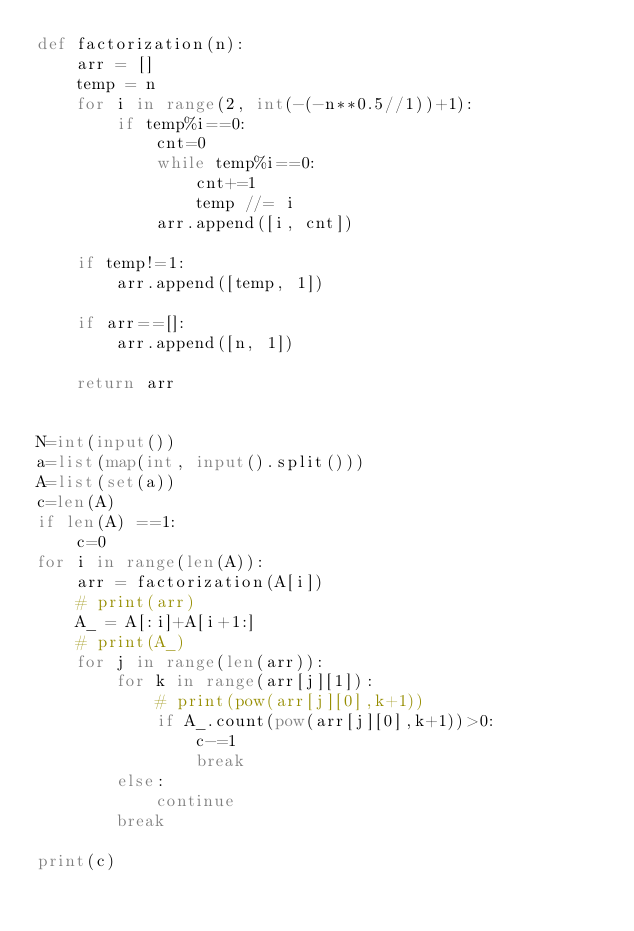Convert code to text. <code><loc_0><loc_0><loc_500><loc_500><_Python_>def factorization(n):
    arr = []
    temp = n
    for i in range(2, int(-(-n**0.5//1))+1):
        if temp%i==0:
            cnt=0
            while temp%i==0:
                cnt+=1
                temp //= i
            arr.append([i, cnt])

    if temp!=1:
        arr.append([temp, 1])

    if arr==[]:
        arr.append([n, 1])

    return arr


N=int(input())
a=list(map(int, input().split()))
A=list(set(a))
c=len(A)
if len(A) ==1:
    c=0
for i in range(len(A)):
    arr = factorization(A[i])
    # print(arr)
    A_ = A[:i]+A[i+1:]
    # print(A_)
    for j in range(len(arr)):
        for k in range(arr[j][1]):
            # print(pow(arr[j][0],k+1))
            if A_.count(pow(arr[j][0],k+1))>0:
                c-=1
                break
        else:
            continue
        break

print(c)
</code> 